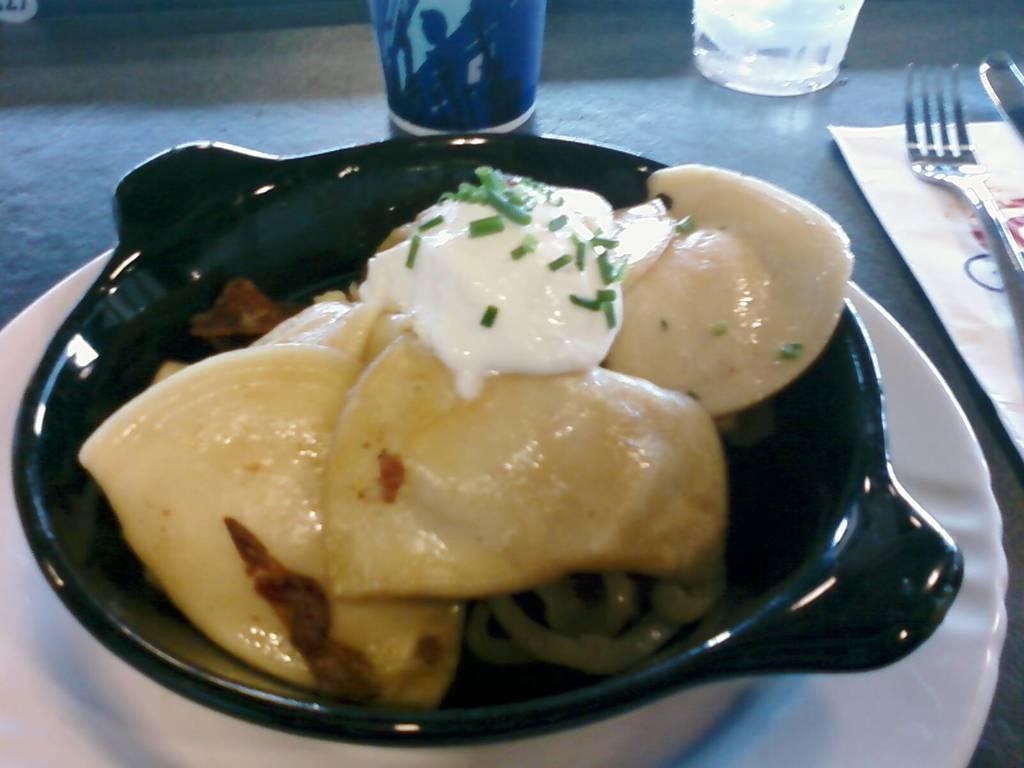Describe this image in one or two sentences. In this picture we can see a table. On the table we can see the glasses, paper, fork, spoon, plate and a bowl which contains food. 